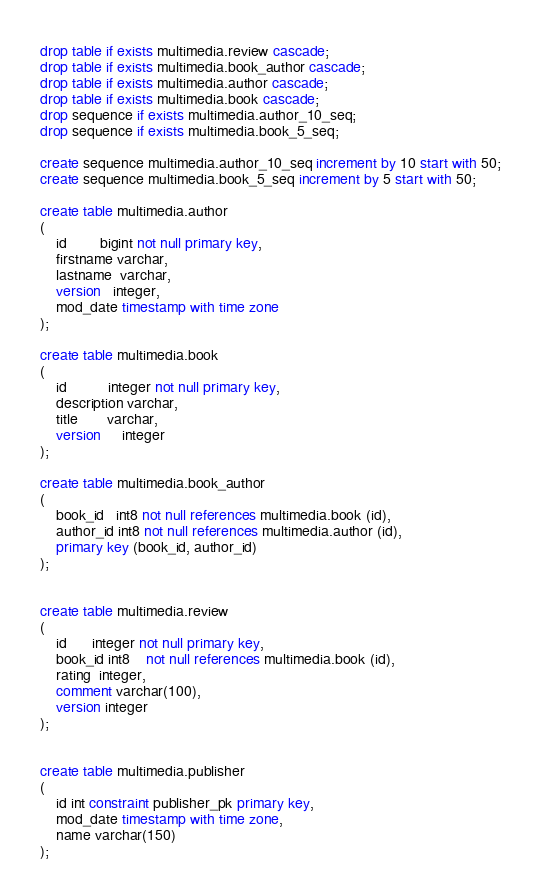Convert code to text. <code><loc_0><loc_0><loc_500><loc_500><_SQL_>
drop table if exists multimedia.review cascade;
drop table if exists multimedia.book_author cascade;
drop table if exists multimedia.author cascade;
drop table if exists multimedia.book cascade;
drop sequence if exists multimedia.author_10_seq;
drop sequence if exists multimedia.book_5_seq;

create sequence multimedia.author_10_seq increment by 10 start with 50;
create sequence multimedia.book_5_seq increment by 5 start with 50;

create table multimedia.author
(
    id        bigint not null primary key,
    firstname varchar,
    lastname  varchar,
    version   integer,
    mod_date timestamp with time zone
);

create table multimedia.book
(
    id          integer not null primary key,
    description varchar,
    title       varchar,
    version     integer
);

create table multimedia.book_author
(
    book_id   int8 not null references multimedia.book (id),
    author_id int8 not null references multimedia.author (id),
    primary key (book_id, author_id)
);


create table multimedia.review
(
    id      integer not null primary key,
    book_id int8    not null references multimedia.book (id),
    rating  integer,
    comment varchar(100),
    version integer
);


create table multimedia.publisher
(
    id int constraint publisher_pk primary key,
    mod_date timestamp with time zone,
    name varchar(150)
);


</code> 